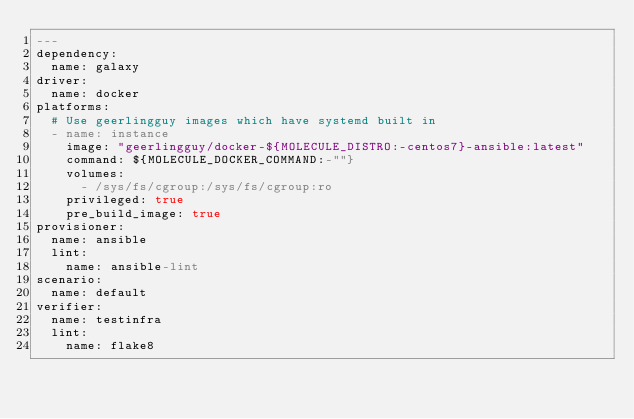Convert code to text. <code><loc_0><loc_0><loc_500><loc_500><_YAML_>---
dependency:
  name: galaxy
driver:
  name: docker
platforms:
  # Use geerlingguy images which have systemd built in
  - name: instance
    image: "geerlingguy/docker-${MOLECULE_DISTRO:-centos7}-ansible:latest"
    command: ${MOLECULE_DOCKER_COMMAND:-""}
    volumes:
      - /sys/fs/cgroup:/sys/fs/cgroup:ro
    privileged: true
    pre_build_image: true
provisioner:
  name: ansible
  lint:
    name: ansible-lint
scenario:
  name: default
verifier:
  name: testinfra
  lint:
    name: flake8
</code> 